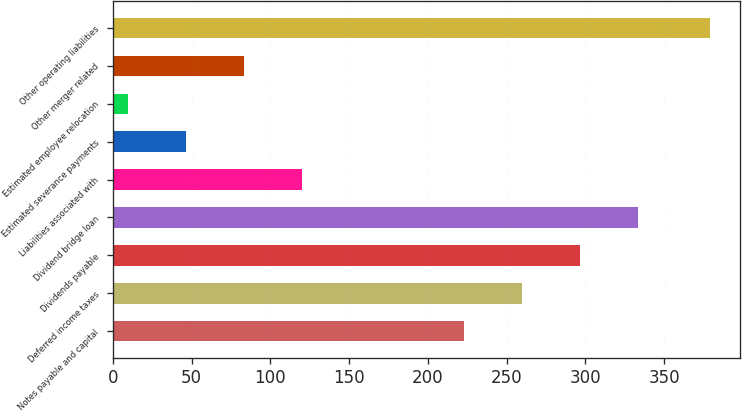Convert chart. <chart><loc_0><loc_0><loc_500><loc_500><bar_chart><fcel>Notes payable and capital<fcel>Deferred income taxes<fcel>Dividends payable<fcel>Dividend bridge loan<fcel>Liabilities associated with<fcel>Estimated severance payments<fcel>Estimated employee relocation<fcel>Other merger related<fcel>Other operating liabilities<nl><fcel>222.8<fcel>259.76<fcel>296.72<fcel>333.68<fcel>120.38<fcel>46.46<fcel>9.5<fcel>83.42<fcel>379.1<nl></chart> 